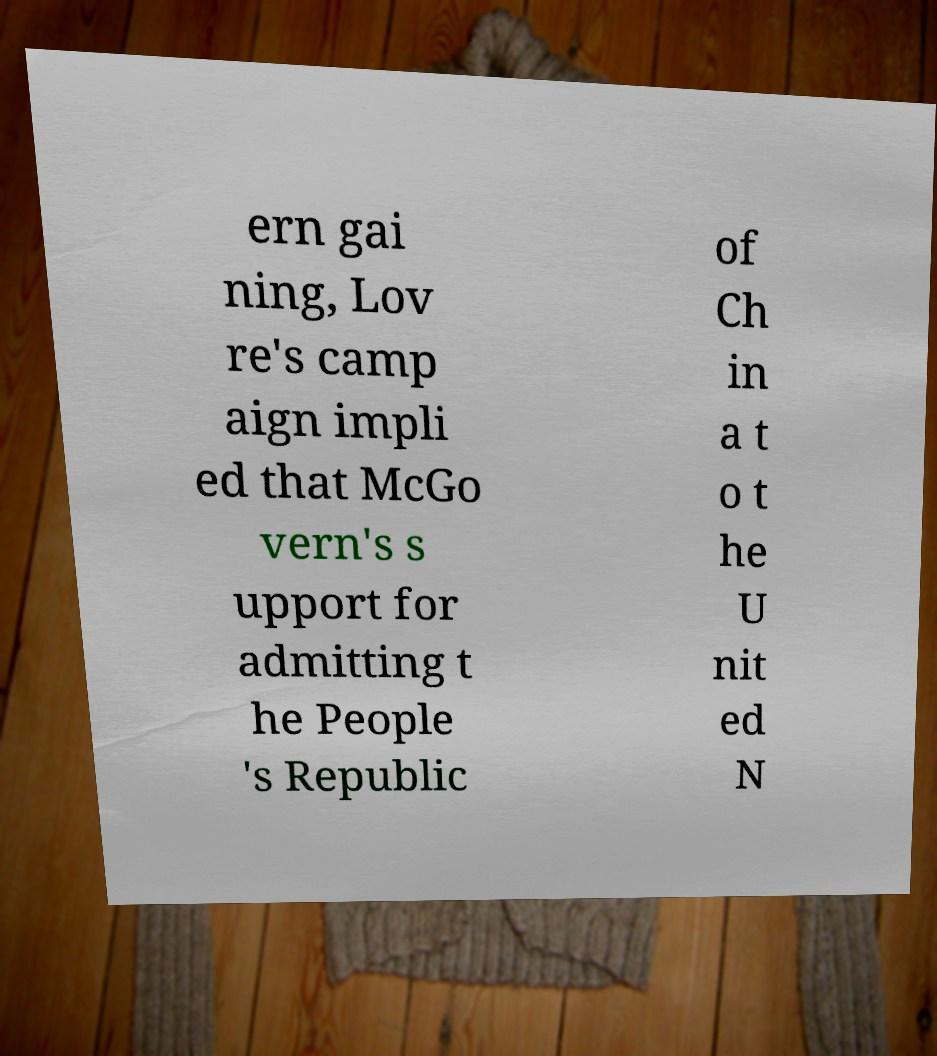Please read and relay the text visible in this image. What does it say? ern gai ning, Lov re's camp aign impli ed that McGo vern's s upport for admitting t he People 's Republic of Ch in a t o t he U nit ed N 